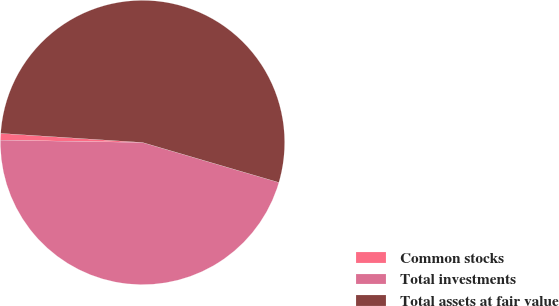<chart> <loc_0><loc_0><loc_500><loc_500><pie_chart><fcel>Common stocks<fcel>Total investments<fcel>Total assets at fair value<nl><fcel>0.76%<fcel>45.72%<fcel>53.52%<nl></chart> 